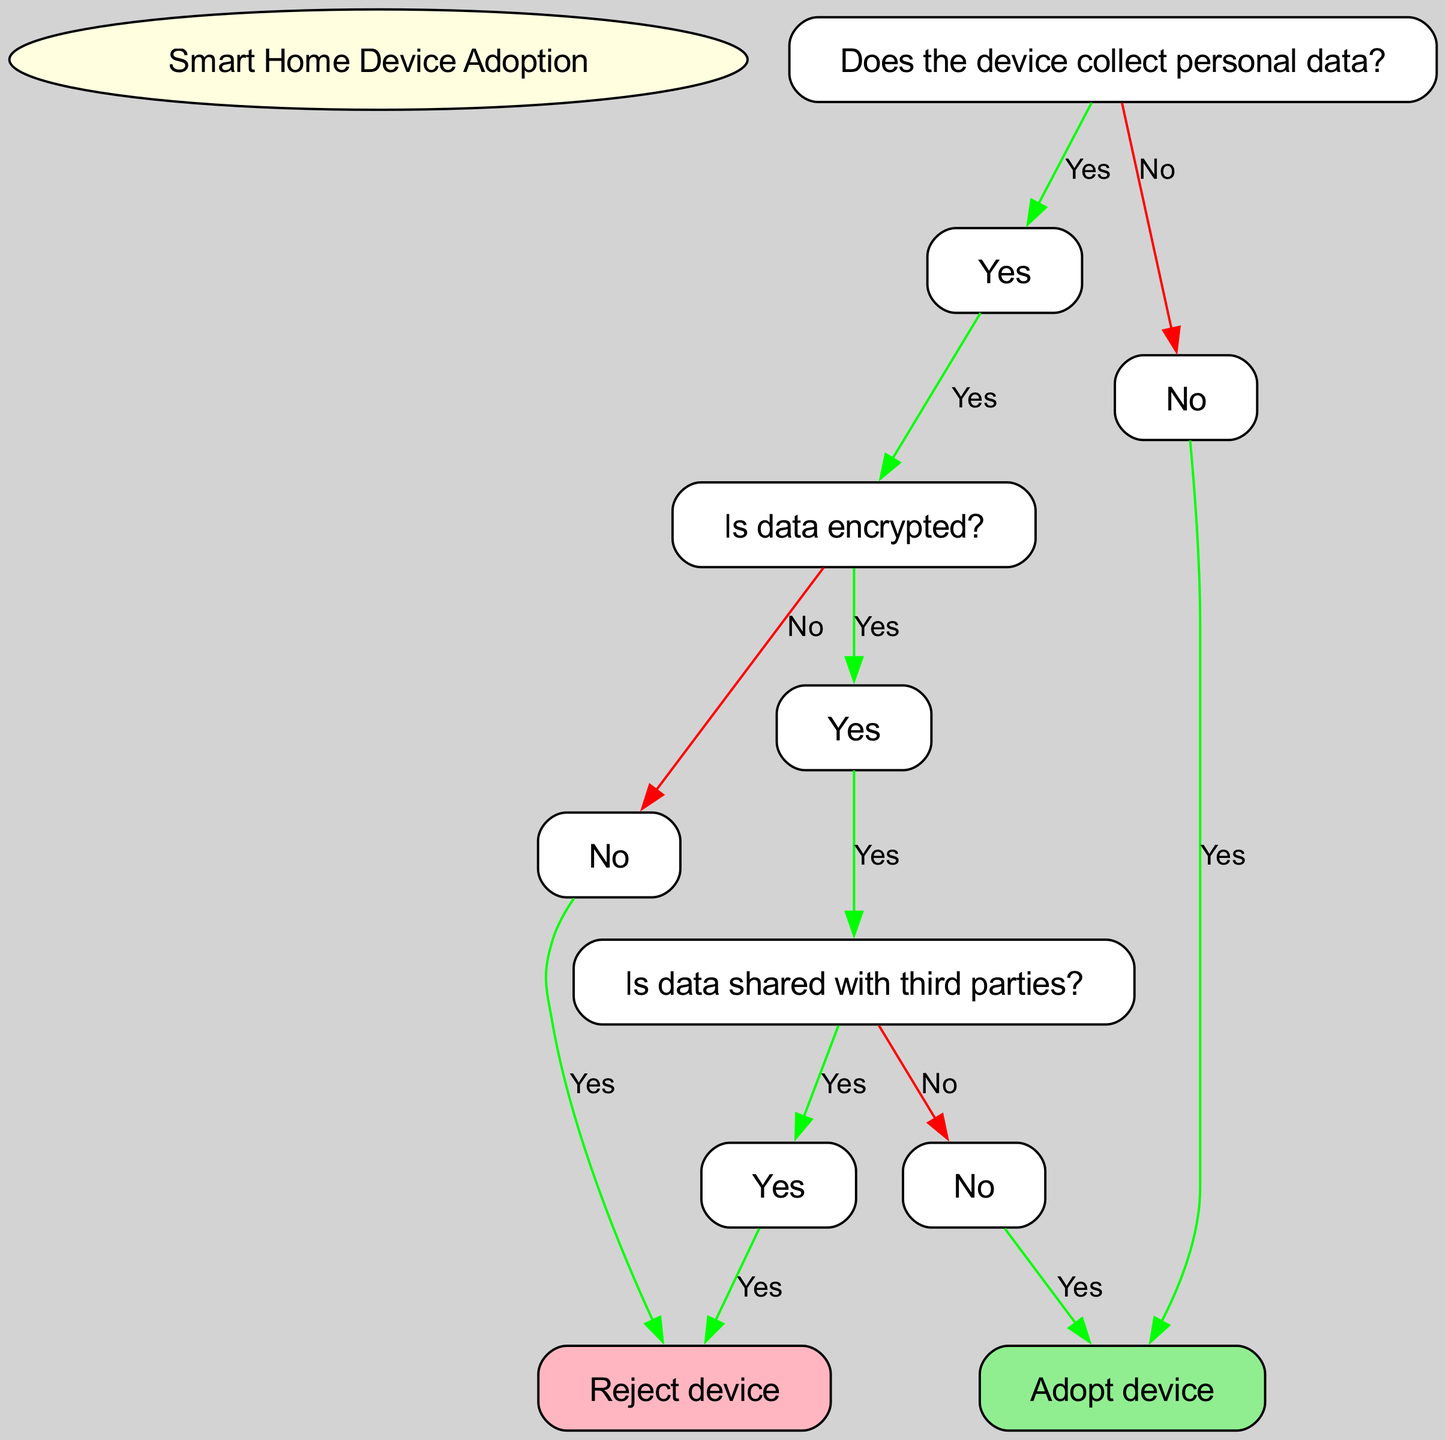What is the root node labeled as? The root node is the starting point of the decision tree and is labeled "Smart Home Device Adoption."
Answer: Smart Home Device Adoption How many children does the node "Data Collection" have? The "Data Collection" node has two children: "Yes" and "No."
Answer: 2 If the device does not collect personal data, what is the final decision? For the "No" branch under "Data Collection," the decision is to "Adopt device."
Answer: Adopt device What happens if the data is not encrypted? Under the "Yes" branch for "Data Collection," if "No" is the answer for "Is data encrypted?", the decision is to "Reject device."
Answer: Reject device How many total decisions (adopt or reject) are indicated in the tree? There are three final decisions: "Adopt device" (two instances) and "Reject device" (two instances), which counts to four total decisions overall.
Answer: 4 If data is encrypted but shared with third parties, what is the user’s decision? If the user selects "Yes" for data encryption and "Yes" for data shared with third parties, the decision will be to "Reject device."
Answer: Reject device What is the color associated with the "Reject device" node? In the diagram, the "Reject device" node is filled with light pink color to indicate a rejection decision.
Answer: Light pink What is the relationship between data encryption and adopting a device? The decision to adopt a device depends on whether the data is encrypted; specifically, if data is encrypted and not shared with third parties, the device can be adopted.
Answer: Adopt device If the device does collect data but it's encrypted and not shared, what should a user do? Following the flow: if data is collected (Yes), and it's encrypted (Yes), and not shared with third parties (No), the decision is to "Adopt device."
Answer: Adopt device 